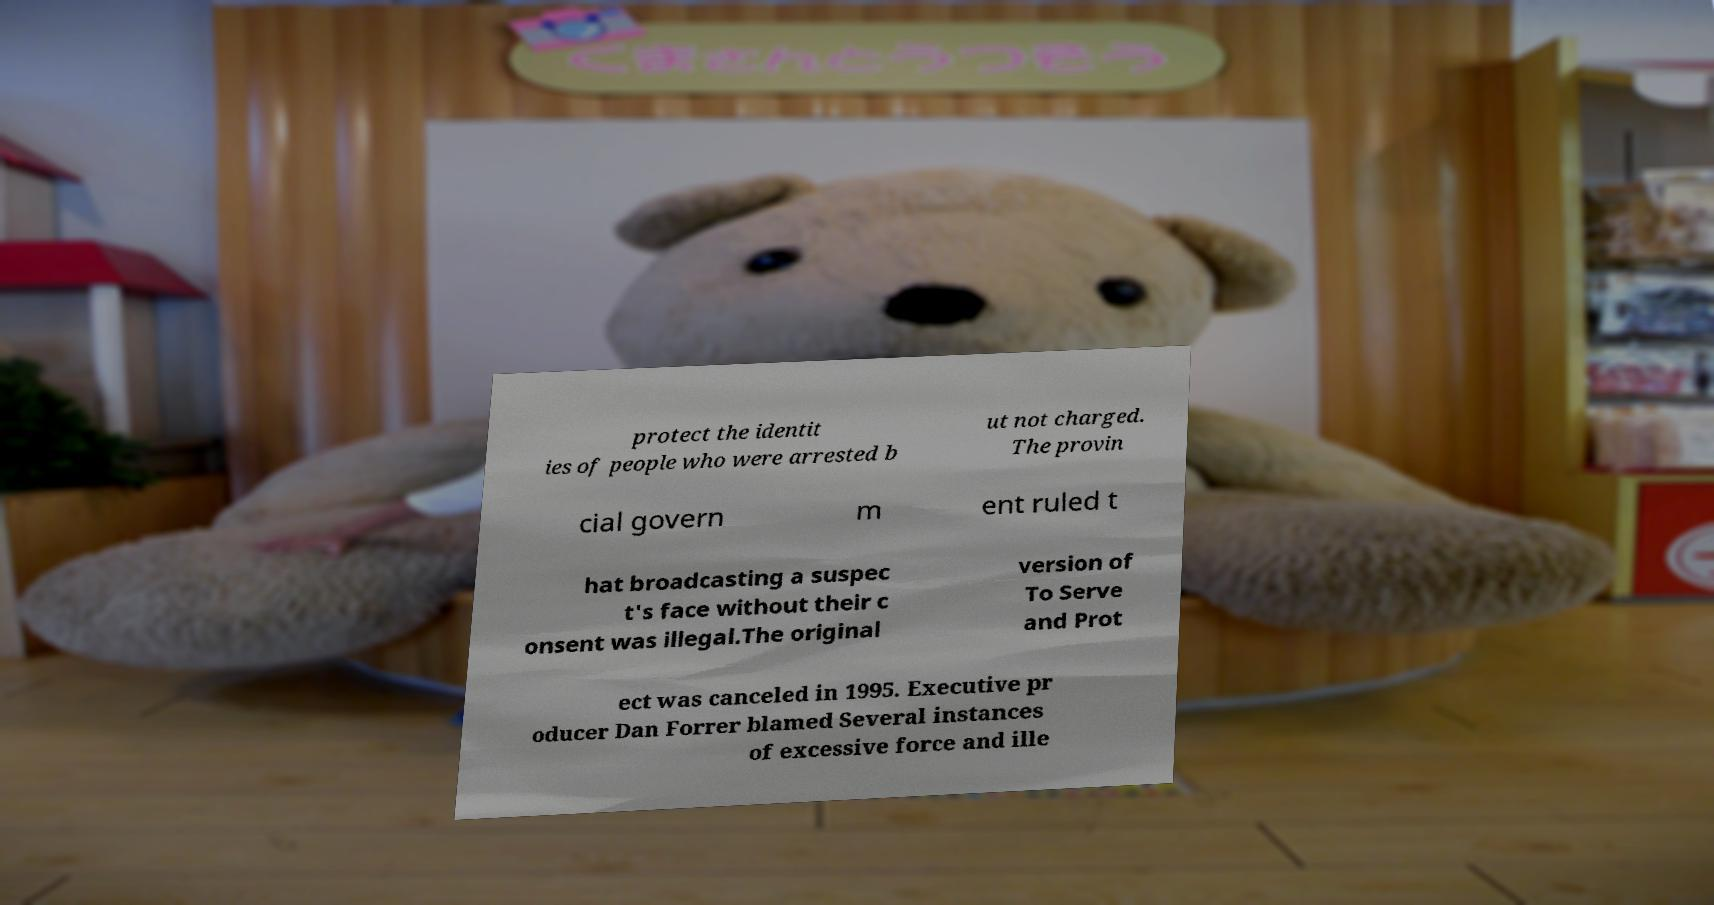Please identify and transcribe the text found in this image. protect the identit ies of people who were arrested b ut not charged. The provin cial govern m ent ruled t hat broadcasting a suspec t's face without their c onsent was illegal.The original version of To Serve and Prot ect was canceled in 1995. Executive pr oducer Dan Forrer blamed Several instances of excessive force and ille 